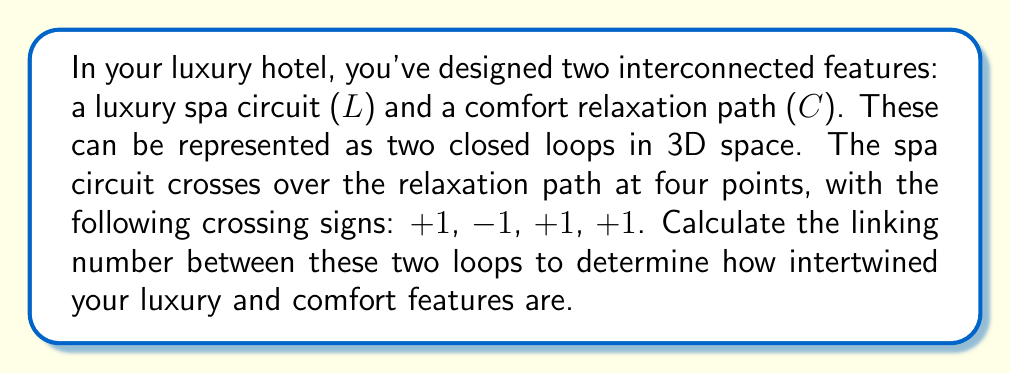Teach me how to tackle this problem. To calculate the linking number between two closed loops, we follow these steps:

1) The linking number is defined as half the sum of the crossing signs:

   $$ Lk(L,C) = \frac{1}{2} \sum_{i} \epsilon_i $$

   where $\epsilon_i$ is the sign of the i-th crossing (+1 for over, -1 for under).

2) In this case, we have four crossings with signs: +1, -1, +1, +1

3) Sum the crossing signs:

   $$ \sum_{i} \epsilon_i = (+1) + (-1) + (+1) + (+1) = 2 $$

4) Divide the sum by 2:

   $$ Lk(L,C) = \frac{1}{2} (2) = 1 $$

The linking number is 1, indicating that the luxury spa circuit and the comfort relaxation path are linked once in a right-handed sense. This suggests a balanced intertwining of luxury and comfort features in your hotel design.
Answer: 1 